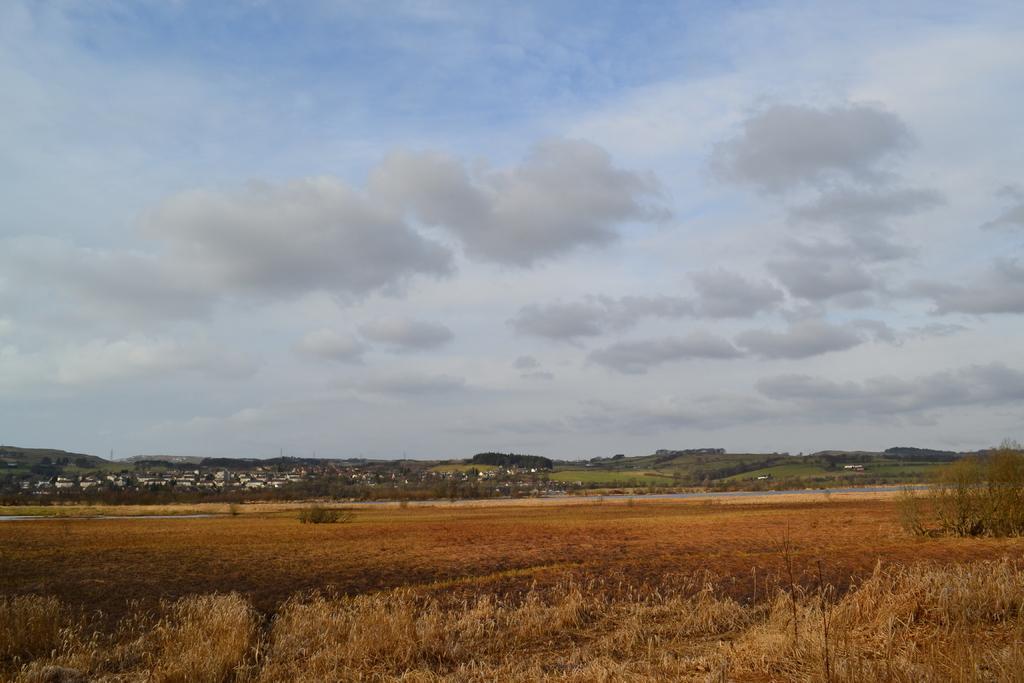How would you summarize this image in a sentence or two? In this image we can see sky, clouds, grass, trees, buildings and houses. 